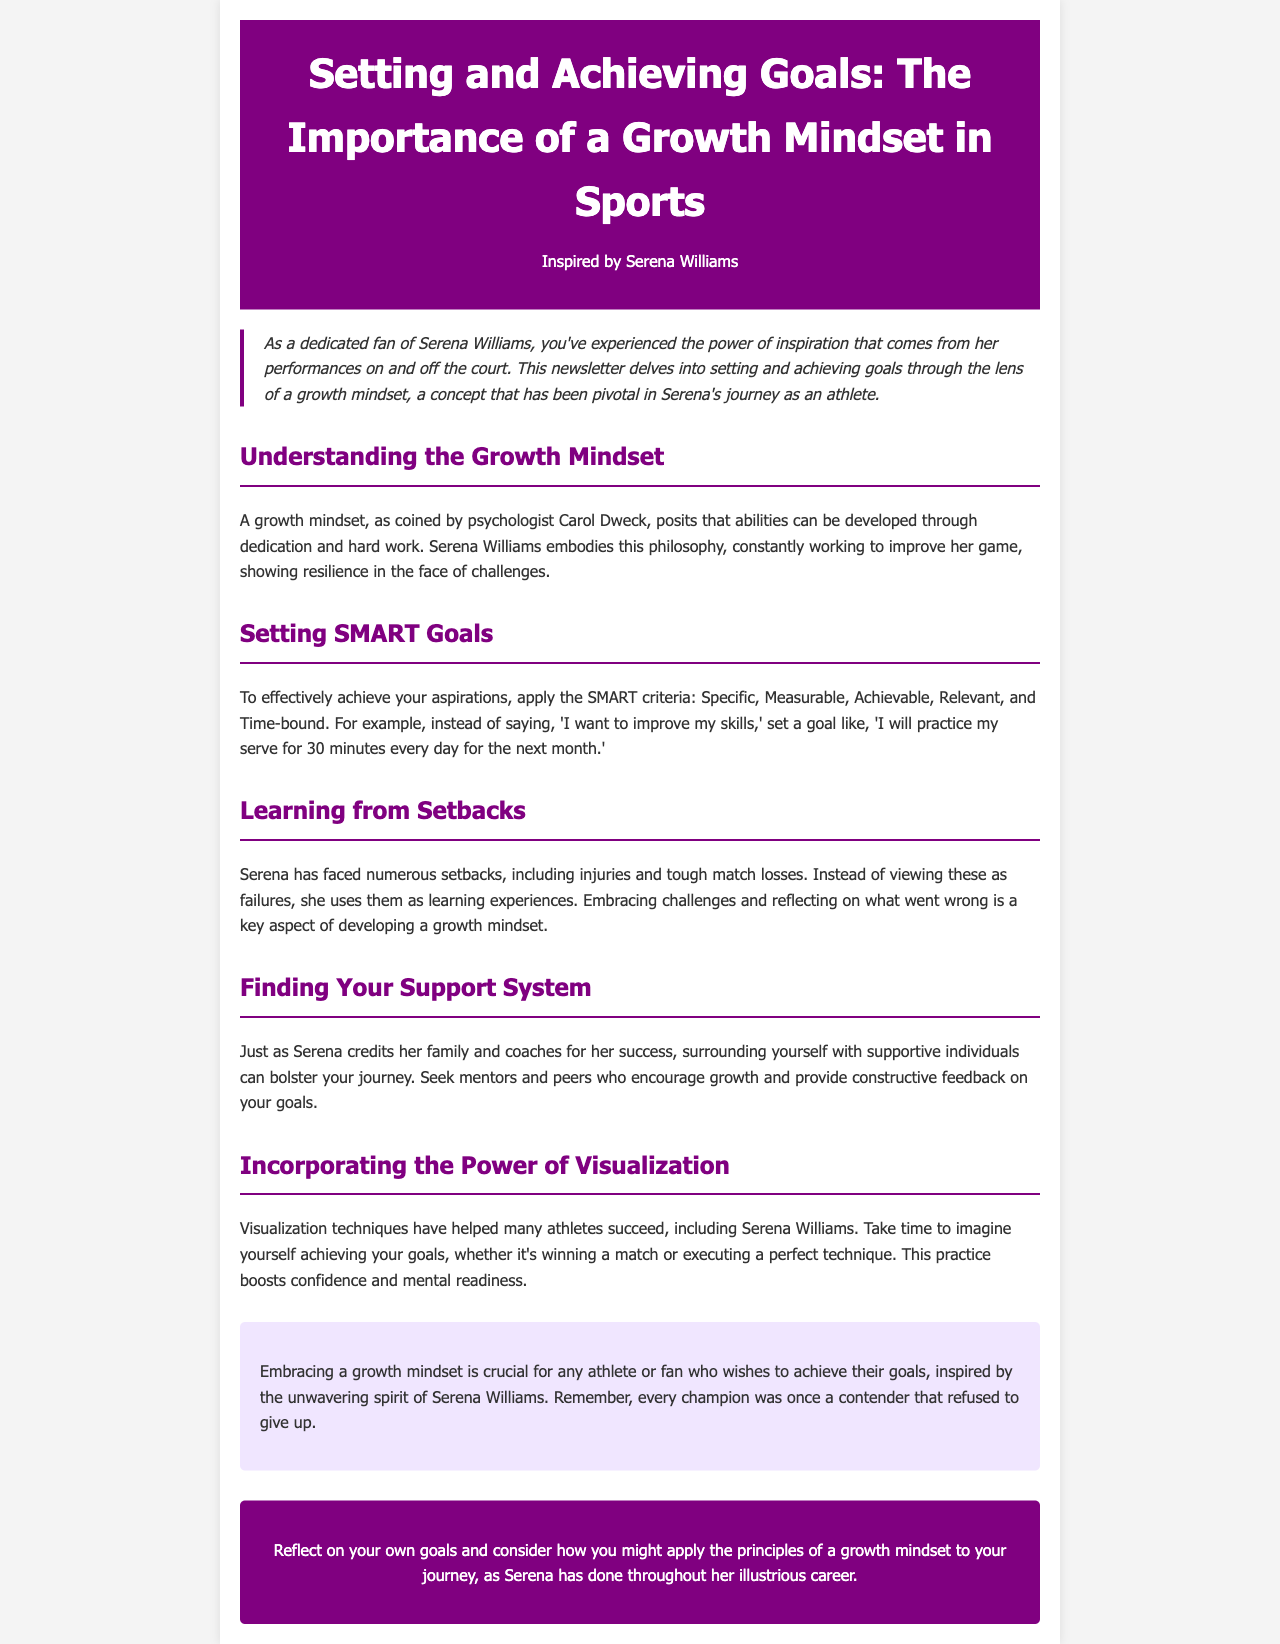What is the title of the newsletter? The title of the newsletter is stated at the top of the document.
Answer: Setting and Achieving Goals: The Importance of a Growth Mindset in Sports Who is the athlete that inspired this newsletter? The newsletter mentions the athlete who inspired it in the header.
Answer: Serena Williams What does SMART stand for in goal setting? The newsletter provides the criteria for effective goals which are explained throughout the document.
Answer: Specific, Measurable, Achievable, Relevant, Time-bound What key aspect does Serena focus on when facing setbacks? The section on learning from setbacks explains Serena's approach to challenges.
Answer: Learning experiences What visualization technique is mentioned in the newsletter? The newsletter discusses a specific mental preparation method used by athletes.
Answer: Visualization techniques How does the newsletter suggest finding a support system? The section on finding your support system advises seeking supportive individuals.
Answer: Family and coaches What is a crucial mindset emphasized in the newsletter for achieving goals? The document repeatedly discusses a certain mindset throughout various sections.
Answer: Growth mindset What does every champion need to be considered, according to the newsletter? The conclusion implies a particular characteristic every champion shares.
Answer: Contender 